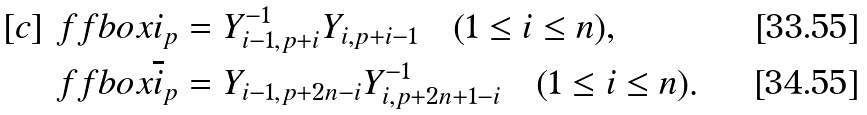<formula> <loc_0><loc_0><loc_500><loc_500>[ c ] & \ f f b o x { i } _ { p } = Y _ { i - 1 , p + i } ^ { - 1 } Y _ { i , p + { i - 1 } } \quad ( 1 \leq i \leq n ) , \\ & \ f f b o x { \overline { i } } _ { p } = Y _ { i - 1 , p + { 2 n - i } } Y _ { i , p + { 2 n + 1 - i } } ^ { - 1 } \quad ( 1 \leq i \leq n ) .</formula> 